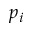<formula> <loc_0><loc_0><loc_500><loc_500>p _ { i }</formula> 